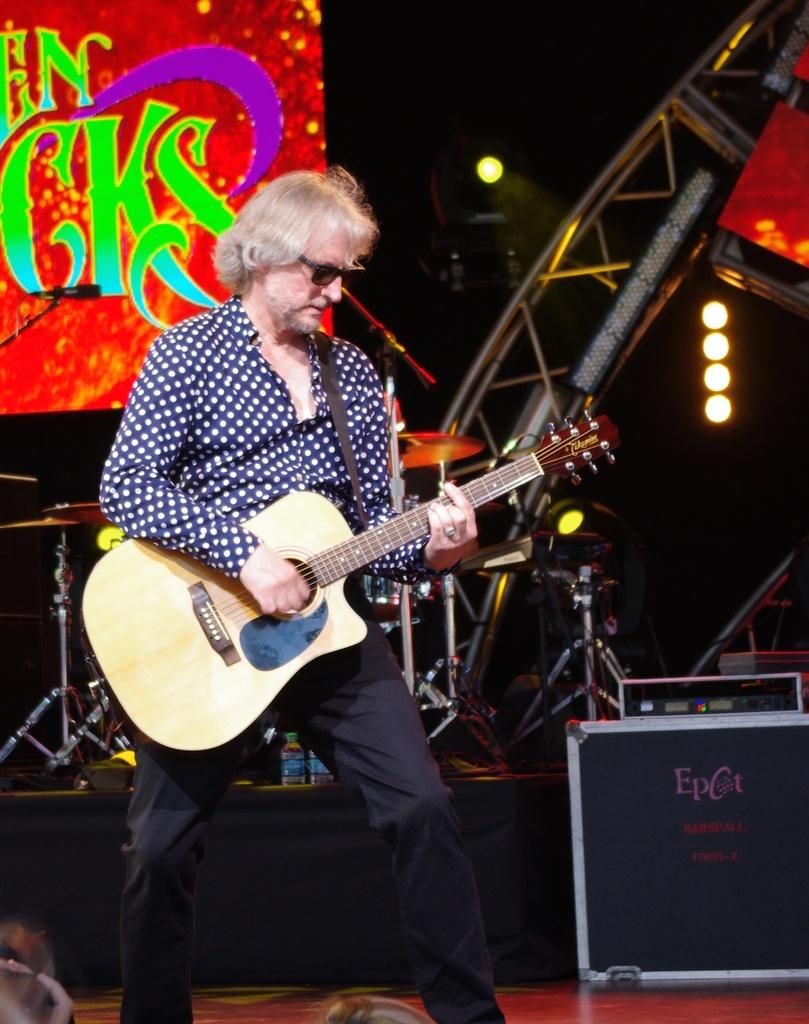Who is the main subject in the image? There is a man in the image. What is the man holding in the image? The man is holding a guitar. What is the man doing with the guitar? The man is playing the guitar. What else can be seen in the background of the image? There are musical instruments and a hoarding in the background of the image. What type of riddle is the man trying to solve in the image? There is no riddle present in the image; the man is playing a guitar. Where is the man going on vacation in the image? There is no indication of a vacation in the image; the man is playing a guitar. 